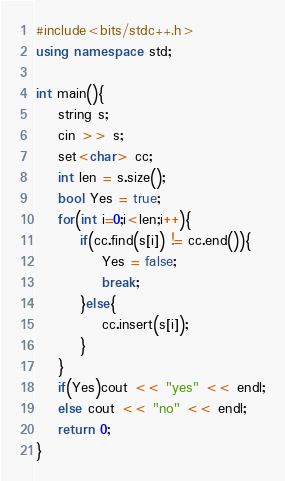Convert code to text. <code><loc_0><loc_0><loc_500><loc_500><_C++_>#include<bits/stdc++.h>
using namespace std;

int main(){
    string s;
    cin >> s;
    set<char> cc;
    int len = s.size();
    bool Yes = true;
    for(int i=0;i<len;i++){
        if(cc.find(s[i]) != cc.end()){
            Yes = false;
            break;
        }else{
            cc.insert(s[i]);
        }
    }
    if(Yes)cout << "yes" << endl;
    else cout << "no" << endl;
    return 0;
}</code> 